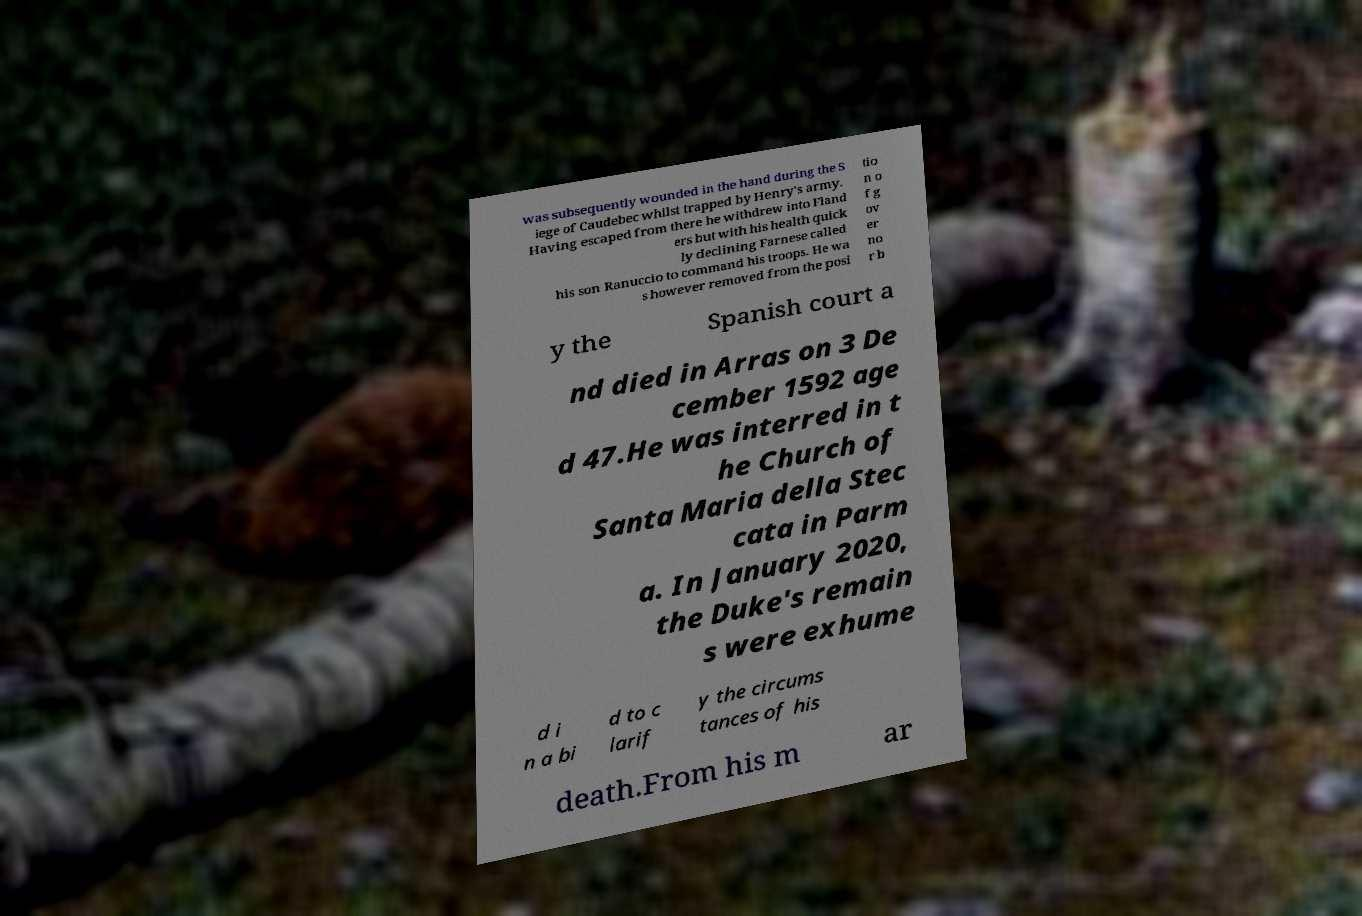Please identify and transcribe the text found in this image. was subsequently wounded in the hand during the S iege of Caudebec whilst trapped by Henry's army. Having escaped from there he withdrew into Fland ers but with his health quick ly declining Farnese called his son Ranuccio to command his troops. He wa s however removed from the posi tio n o f g ov er no r b y the Spanish court a nd died in Arras on 3 De cember 1592 age d 47.He was interred in t he Church of Santa Maria della Stec cata in Parm a. In January 2020, the Duke's remain s were exhume d i n a bi d to c larif y the circums tances of his death.From his m ar 